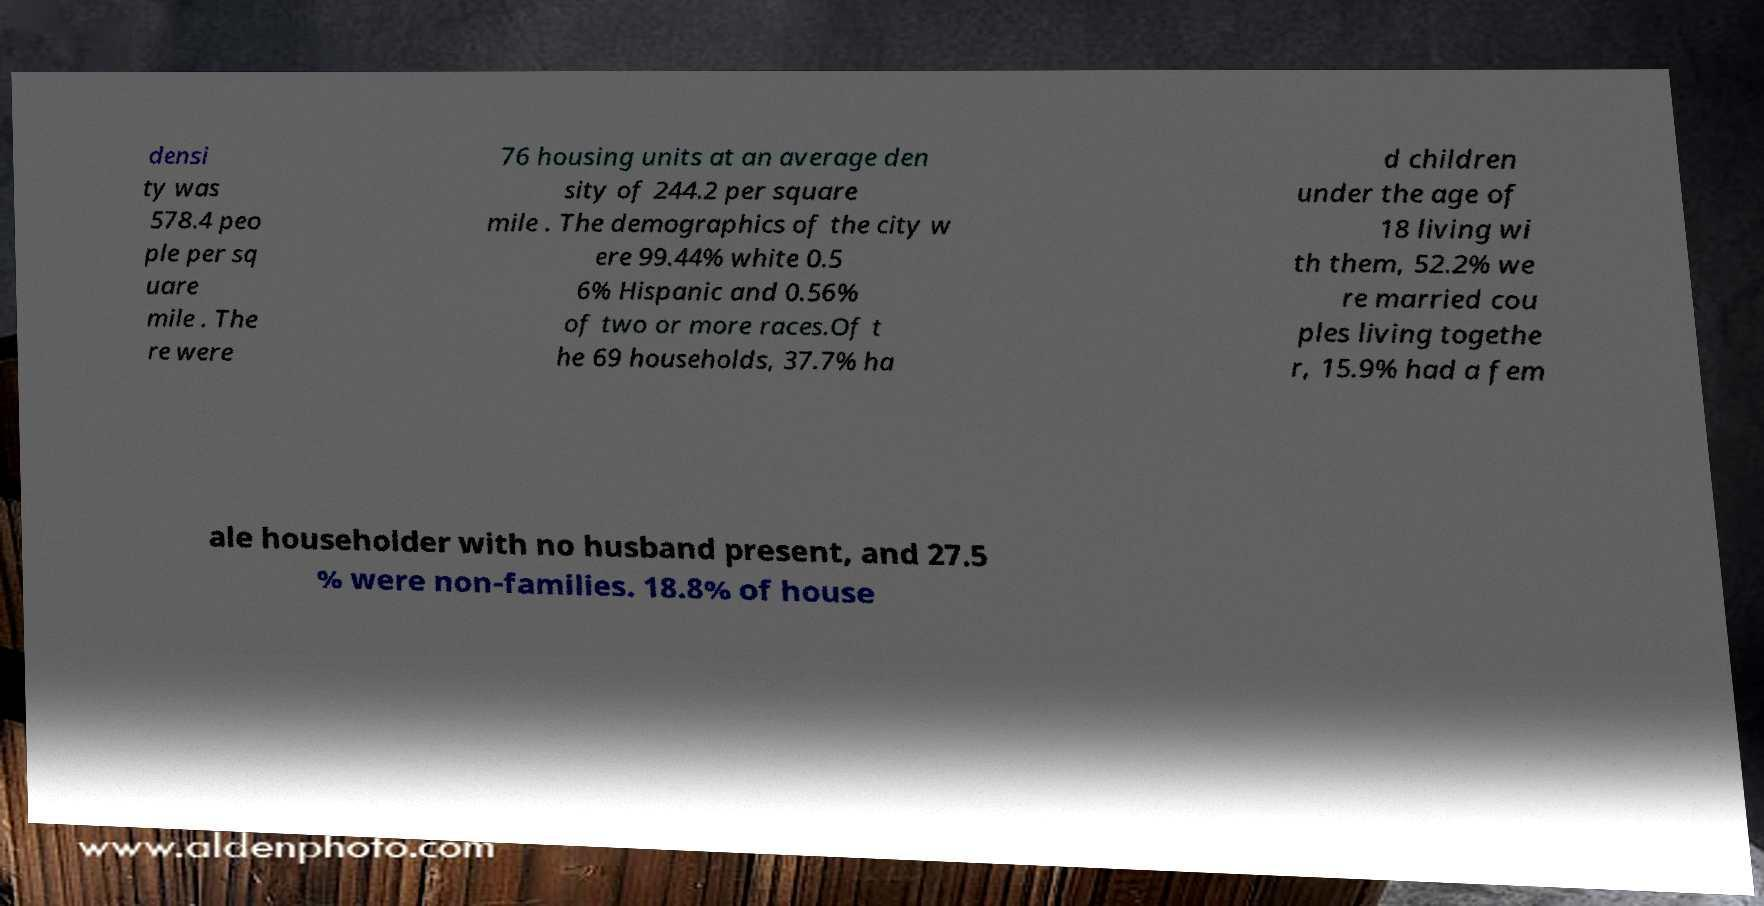Can you read and provide the text displayed in the image?This photo seems to have some interesting text. Can you extract and type it out for me? densi ty was 578.4 peo ple per sq uare mile . The re were 76 housing units at an average den sity of 244.2 per square mile . The demographics of the city w ere 99.44% white 0.5 6% Hispanic and 0.56% of two or more races.Of t he 69 households, 37.7% ha d children under the age of 18 living wi th them, 52.2% we re married cou ples living togethe r, 15.9% had a fem ale householder with no husband present, and 27.5 % were non-families. 18.8% of house 